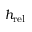Convert formula to latex. <formula><loc_0><loc_0><loc_500><loc_500>h _ { r e l }</formula> 